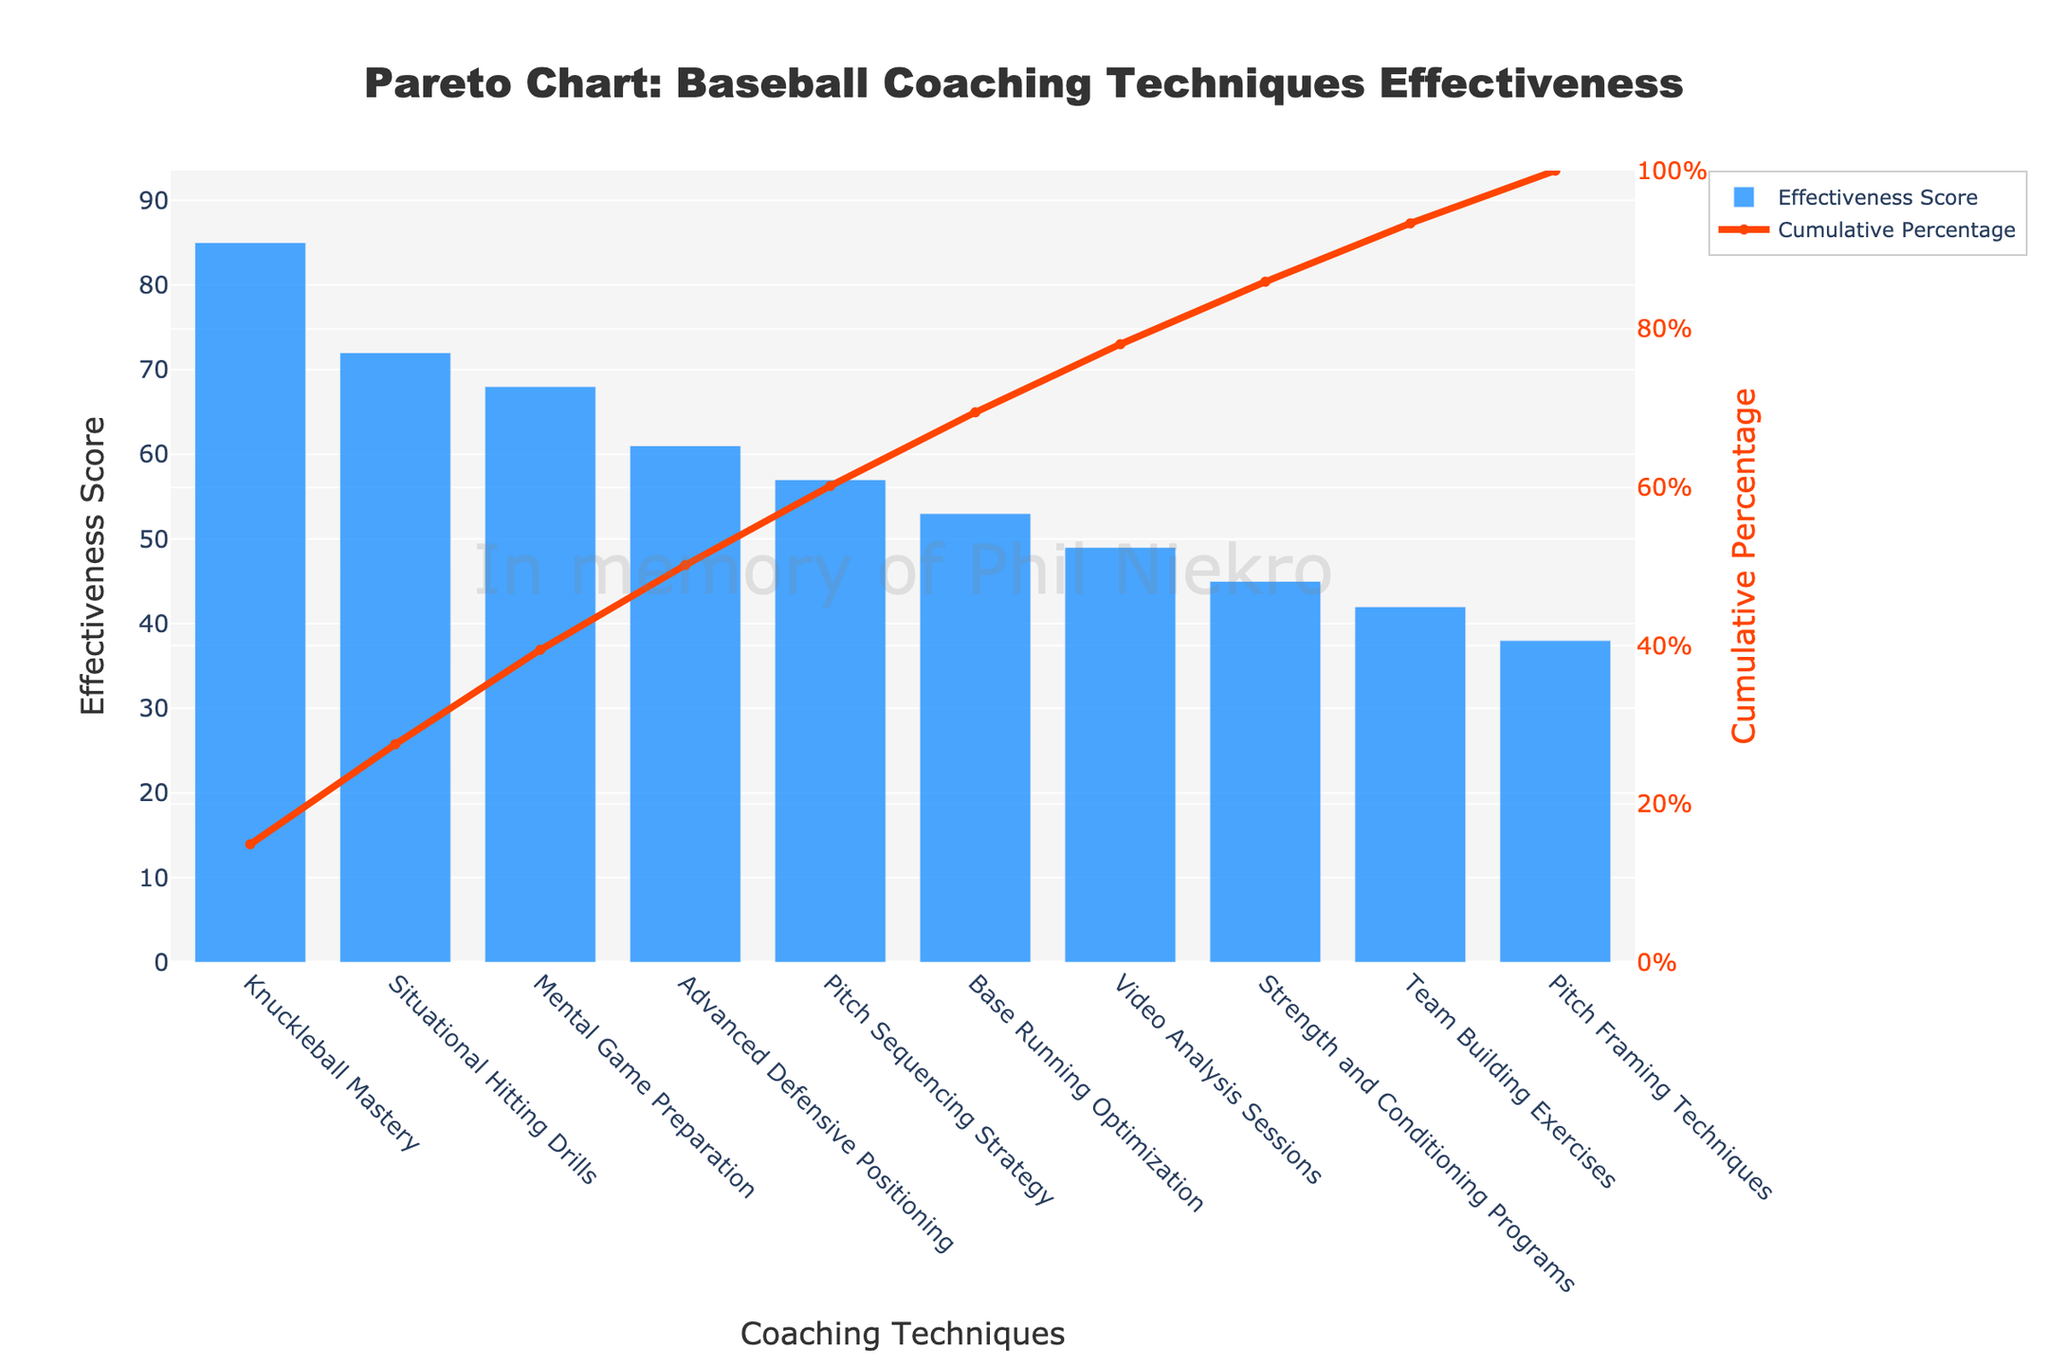What's the title of the Pareto chart? The title is displayed at the top center of the figure. It reads, "Pareto Chart: Baseball Coaching Techniques Effectiveness."
Answer: Pareto Chart: Baseball Coaching Techniques Effectiveness What technique has the highest effectiveness score? The technique with the tallest bar represents the highest effectiveness score. It's the first bar labeled "Knuckleball Mastery" with a score of 85.
Answer: Knuckleball Mastery What's the color of the bar chart representing the effectiveness score? The color of the bars is uniformly represented by a blue shade.
Answer: Blue What is the cumulative percentage when adding the top two coaching techniques? The cumulative percentage can be found by locating the line chart points corresponding to the top two bars. These techniques are "Knuckleball Mastery" and "Situational Hitting Drills" with cumulative percentages of 34.69% and 64.29%, respectively. Therefore, adding these gives 34.69% + 29.60% = 64.29%.
Answer: 64.29% Which coaching technique has a cumulative percentage closest to 80%? You can find the technique by looking at the line chart and finding the technique closest to 80%. Here, "Pitch Sequencing Strategy" is closest with a cumulative percentage just over 80%.
Answer: Pitch Sequencing Strategy What are the effectiveness scores of the top three techniques? By observing the heights of the top three bars in descending order: "Knuckleball Mastery" (85), "Situational Hitting Drills" (72), and "Mental Game Preparation" (68).
Answer: 85, 72, 68 How does the effectiveness score of "Pitch Sequencing Strategy" compare to "Base Running Optimization"? The bar for "Pitch Sequencing Strategy" is taller than that of "Base Running Optimization," showing higher effectiveness scores of 57 and 53 respectively.
Answer: "Pitch Sequencing Strategy" is higher What cumulative percentage does the technique "Video Analysis Sessions" add to? Trace the technique "Video Analysis Sessions" to the corresponding point on the line chart. The cumulative percentage at "Video Analysis Sessions" is about 73.74%.
Answer: 73.74% How many techniques have an effectiveness score greater than 50? By counting the bars with heights indicating scores above 50, we find: "Knuckleball Mastery," "Situational Hitting Drills," "Mental Game Preparation," "Advanced Defensive Positioning," and "Pitch Sequencing Strategy" (a total of 5 techniques).
Answer: 5 techniques What is the effectiveness score of the least effective technique? The shortest bar indicates the least effective technique, which is "Pitch Framing Techniques" with a score of 38.
Answer: 38 